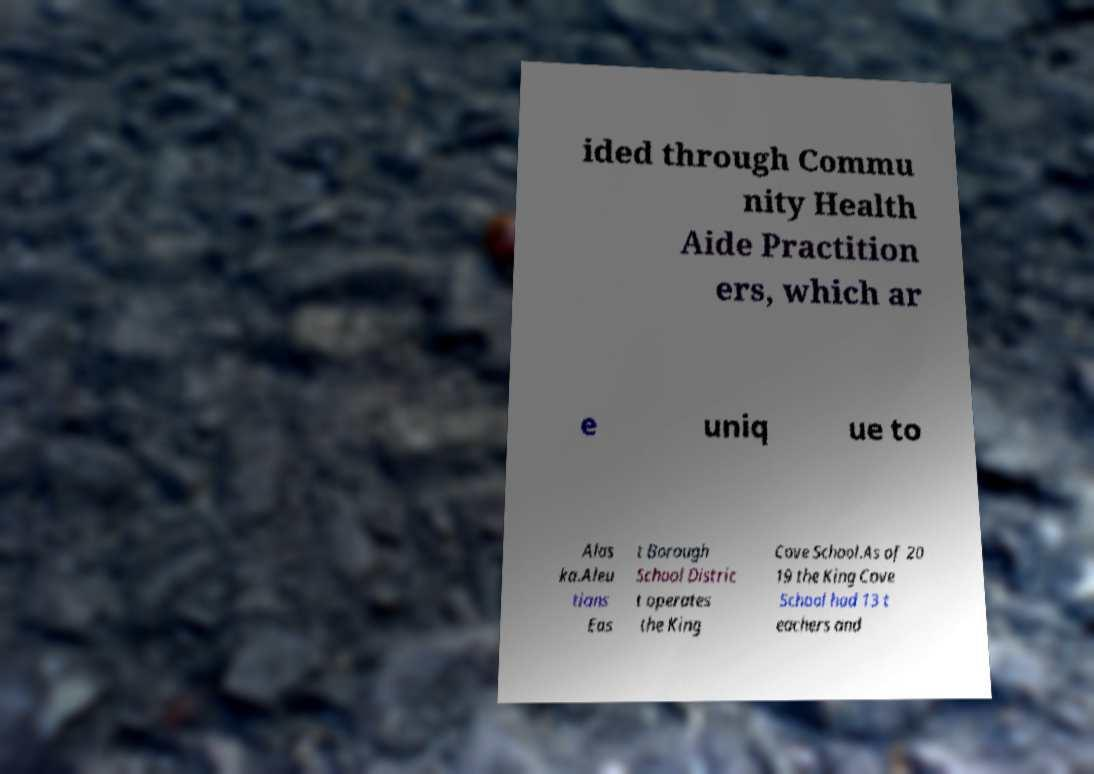Please read and relay the text visible in this image. What does it say? ided through Commu nity Health Aide Practition ers, which ar e uniq ue to Alas ka.Aleu tians Eas t Borough School Distric t operates the King Cove School.As of 20 19 the King Cove School had 13 t eachers and 